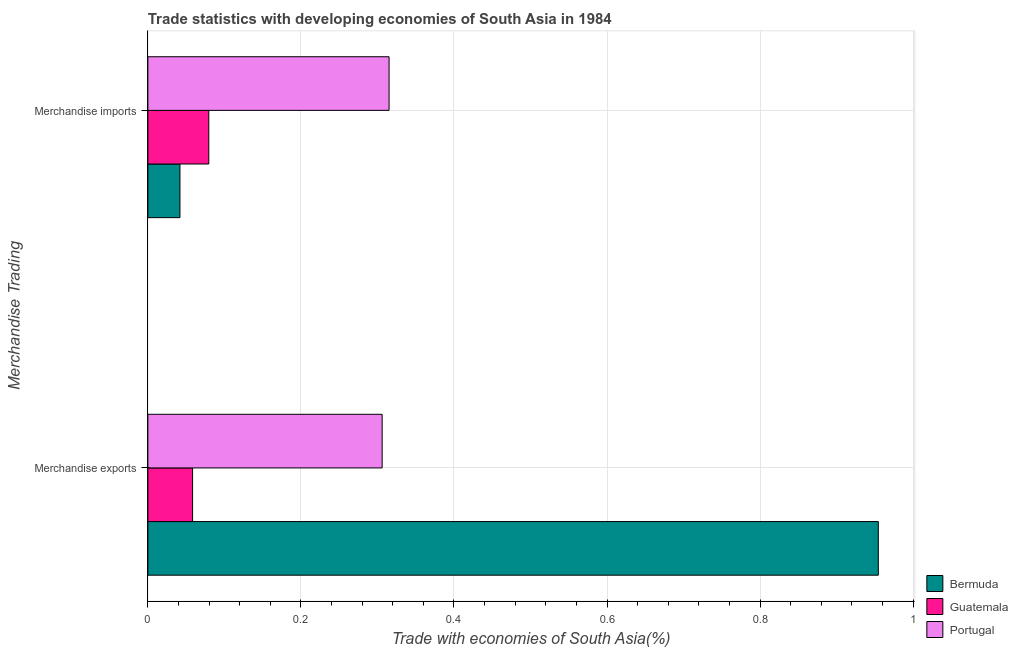How many groups of bars are there?
Give a very brief answer. 2. What is the label of the 1st group of bars from the top?
Keep it short and to the point. Merchandise imports. What is the merchandise imports in Bermuda?
Your response must be concise. 0.04. Across all countries, what is the maximum merchandise exports?
Offer a terse response. 0.95. Across all countries, what is the minimum merchandise imports?
Keep it short and to the point. 0.04. In which country was the merchandise imports maximum?
Keep it short and to the point. Portugal. In which country was the merchandise imports minimum?
Offer a terse response. Bermuda. What is the total merchandise imports in the graph?
Your answer should be compact. 0.44. What is the difference between the merchandise exports in Portugal and that in Guatemala?
Provide a short and direct response. 0.25. What is the difference between the merchandise exports in Guatemala and the merchandise imports in Bermuda?
Provide a succinct answer. 0.02. What is the average merchandise imports per country?
Give a very brief answer. 0.15. What is the difference between the merchandise exports and merchandise imports in Guatemala?
Offer a very short reply. -0.02. What is the ratio of the merchandise imports in Guatemala to that in Portugal?
Provide a short and direct response. 0.25. Is the merchandise imports in Portugal less than that in Guatemala?
Your answer should be very brief. No. In how many countries, is the merchandise exports greater than the average merchandise exports taken over all countries?
Offer a very short reply. 1. What does the 3rd bar from the top in Merchandise exports represents?
Provide a succinct answer. Bermuda. What does the 1st bar from the bottom in Merchandise imports represents?
Ensure brevity in your answer.  Bermuda. How many bars are there?
Keep it short and to the point. 6. Are all the bars in the graph horizontal?
Your answer should be very brief. Yes. Are the values on the major ticks of X-axis written in scientific E-notation?
Your answer should be compact. No. Does the graph contain grids?
Offer a very short reply. Yes. Where does the legend appear in the graph?
Provide a short and direct response. Bottom right. How many legend labels are there?
Your response must be concise. 3. What is the title of the graph?
Ensure brevity in your answer.  Trade statistics with developing economies of South Asia in 1984. Does "Kenya" appear as one of the legend labels in the graph?
Provide a succinct answer. No. What is the label or title of the X-axis?
Keep it short and to the point. Trade with economies of South Asia(%). What is the label or title of the Y-axis?
Keep it short and to the point. Merchandise Trading. What is the Trade with economies of South Asia(%) of Bermuda in Merchandise exports?
Your response must be concise. 0.95. What is the Trade with economies of South Asia(%) of Guatemala in Merchandise exports?
Your answer should be compact. 0.06. What is the Trade with economies of South Asia(%) of Portugal in Merchandise exports?
Provide a short and direct response. 0.31. What is the Trade with economies of South Asia(%) in Bermuda in Merchandise imports?
Give a very brief answer. 0.04. What is the Trade with economies of South Asia(%) in Guatemala in Merchandise imports?
Offer a very short reply. 0.08. What is the Trade with economies of South Asia(%) of Portugal in Merchandise imports?
Offer a very short reply. 0.32. Across all Merchandise Trading, what is the maximum Trade with economies of South Asia(%) of Bermuda?
Offer a very short reply. 0.95. Across all Merchandise Trading, what is the maximum Trade with economies of South Asia(%) in Guatemala?
Give a very brief answer. 0.08. Across all Merchandise Trading, what is the maximum Trade with economies of South Asia(%) in Portugal?
Your answer should be very brief. 0.32. Across all Merchandise Trading, what is the minimum Trade with economies of South Asia(%) in Bermuda?
Your answer should be compact. 0.04. Across all Merchandise Trading, what is the minimum Trade with economies of South Asia(%) in Guatemala?
Provide a succinct answer. 0.06. Across all Merchandise Trading, what is the minimum Trade with economies of South Asia(%) of Portugal?
Your response must be concise. 0.31. What is the total Trade with economies of South Asia(%) in Guatemala in the graph?
Offer a very short reply. 0.14. What is the total Trade with economies of South Asia(%) in Portugal in the graph?
Give a very brief answer. 0.62. What is the difference between the Trade with economies of South Asia(%) in Bermuda in Merchandise exports and that in Merchandise imports?
Your answer should be compact. 0.91. What is the difference between the Trade with economies of South Asia(%) in Guatemala in Merchandise exports and that in Merchandise imports?
Give a very brief answer. -0.02. What is the difference between the Trade with economies of South Asia(%) in Portugal in Merchandise exports and that in Merchandise imports?
Provide a short and direct response. -0.01. What is the difference between the Trade with economies of South Asia(%) of Bermuda in Merchandise exports and the Trade with economies of South Asia(%) of Guatemala in Merchandise imports?
Your response must be concise. 0.87. What is the difference between the Trade with economies of South Asia(%) of Bermuda in Merchandise exports and the Trade with economies of South Asia(%) of Portugal in Merchandise imports?
Your response must be concise. 0.64. What is the difference between the Trade with economies of South Asia(%) of Guatemala in Merchandise exports and the Trade with economies of South Asia(%) of Portugal in Merchandise imports?
Make the answer very short. -0.26. What is the average Trade with economies of South Asia(%) of Bermuda per Merchandise Trading?
Make the answer very short. 0.5. What is the average Trade with economies of South Asia(%) of Guatemala per Merchandise Trading?
Ensure brevity in your answer.  0.07. What is the average Trade with economies of South Asia(%) in Portugal per Merchandise Trading?
Give a very brief answer. 0.31. What is the difference between the Trade with economies of South Asia(%) of Bermuda and Trade with economies of South Asia(%) of Guatemala in Merchandise exports?
Provide a succinct answer. 0.9. What is the difference between the Trade with economies of South Asia(%) in Bermuda and Trade with economies of South Asia(%) in Portugal in Merchandise exports?
Give a very brief answer. 0.65. What is the difference between the Trade with economies of South Asia(%) in Guatemala and Trade with economies of South Asia(%) in Portugal in Merchandise exports?
Provide a short and direct response. -0.25. What is the difference between the Trade with economies of South Asia(%) of Bermuda and Trade with economies of South Asia(%) of Guatemala in Merchandise imports?
Your answer should be very brief. -0.04. What is the difference between the Trade with economies of South Asia(%) in Bermuda and Trade with economies of South Asia(%) in Portugal in Merchandise imports?
Offer a terse response. -0.27. What is the difference between the Trade with economies of South Asia(%) of Guatemala and Trade with economies of South Asia(%) of Portugal in Merchandise imports?
Make the answer very short. -0.24. What is the ratio of the Trade with economies of South Asia(%) of Bermuda in Merchandise exports to that in Merchandise imports?
Provide a succinct answer. 22.76. What is the ratio of the Trade with economies of South Asia(%) in Guatemala in Merchandise exports to that in Merchandise imports?
Provide a succinct answer. 0.73. What is the ratio of the Trade with economies of South Asia(%) in Portugal in Merchandise exports to that in Merchandise imports?
Your answer should be very brief. 0.97. What is the difference between the highest and the second highest Trade with economies of South Asia(%) in Bermuda?
Keep it short and to the point. 0.91. What is the difference between the highest and the second highest Trade with economies of South Asia(%) of Guatemala?
Provide a succinct answer. 0.02. What is the difference between the highest and the second highest Trade with economies of South Asia(%) of Portugal?
Ensure brevity in your answer.  0.01. What is the difference between the highest and the lowest Trade with economies of South Asia(%) in Bermuda?
Make the answer very short. 0.91. What is the difference between the highest and the lowest Trade with economies of South Asia(%) in Guatemala?
Provide a succinct answer. 0.02. What is the difference between the highest and the lowest Trade with economies of South Asia(%) of Portugal?
Offer a very short reply. 0.01. 